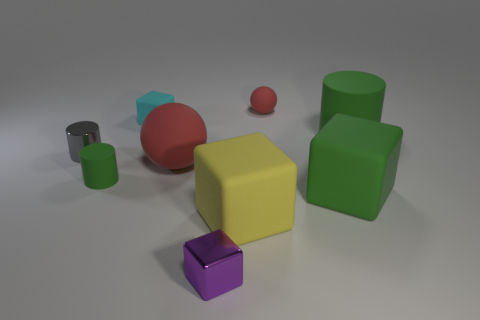There is a rubber block that is on the left side of the small purple shiny thing; is its color the same as the tiny matte cylinder?
Offer a terse response. No. How many things are matte cubes or green things that are in front of the large matte ball?
Your answer should be very brief. 4. There is a tiny matte thing that is on the right side of the small cyan thing; is it the same shape as the large thing that is left of the yellow rubber thing?
Give a very brief answer. Yes. Are there any other things that are the same color as the tiny metallic cylinder?
Provide a succinct answer. No. What shape is the other red thing that is the same material as the big red object?
Ensure brevity in your answer.  Sphere. The thing that is both behind the gray shiny object and to the left of the large sphere is made of what material?
Offer a very short reply. Rubber. Do the tiny rubber block and the small metal cylinder have the same color?
Your response must be concise. No. There is a large object that is the same color as the big rubber cylinder; what is its shape?
Offer a terse response. Cube. What number of small green matte things are the same shape as the small red rubber thing?
Your answer should be very brief. 0. What is the size of the cylinder that is the same material as the purple cube?
Ensure brevity in your answer.  Small. 